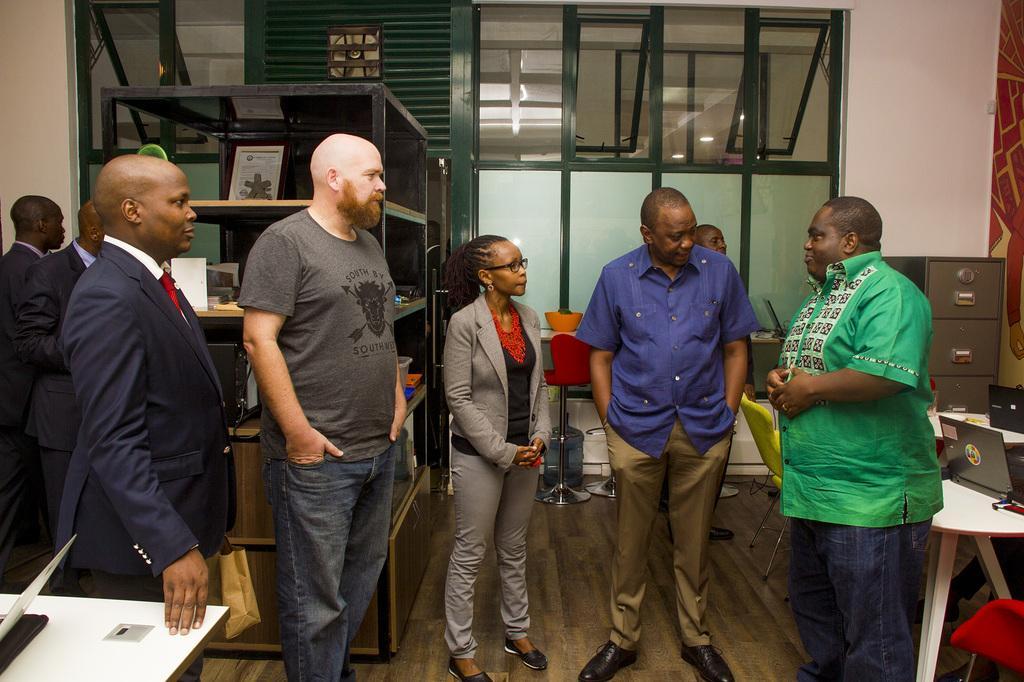How would you summarize this image in a sentence or two? There are few persons standing and there is a table in left and right corner which has some objects on it and there are some other objects in the background. 